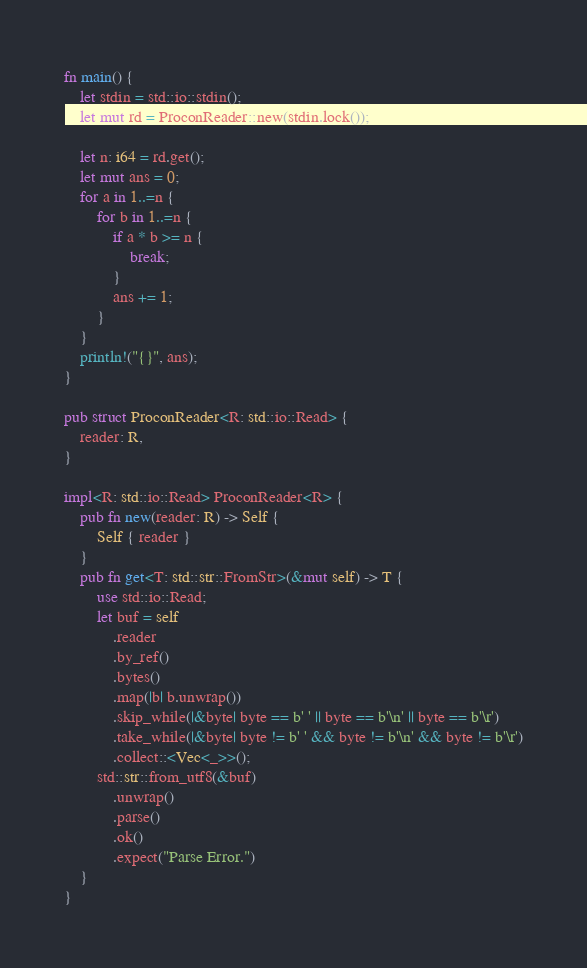Convert code to text. <code><loc_0><loc_0><loc_500><loc_500><_Rust_>fn main() {
    let stdin = std::io::stdin();
    let mut rd = ProconReader::new(stdin.lock());

    let n: i64 = rd.get();
    let mut ans = 0;
    for a in 1..=n {
        for b in 1..=n {
            if a * b >= n {
                break;
            }
            ans += 1;
        }
    }
    println!("{}", ans);
}

pub struct ProconReader<R: std::io::Read> {
    reader: R,
}

impl<R: std::io::Read> ProconReader<R> {
    pub fn new(reader: R) -> Self {
        Self { reader }
    }
    pub fn get<T: std::str::FromStr>(&mut self) -> T {
        use std::io::Read;
        let buf = self
            .reader
            .by_ref()
            .bytes()
            .map(|b| b.unwrap())
            .skip_while(|&byte| byte == b' ' || byte == b'\n' || byte == b'\r')
            .take_while(|&byte| byte != b' ' && byte != b'\n' && byte != b'\r')
            .collect::<Vec<_>>();
        std::str::from_utf8(&buf)
            .unwrap()
            .parse()
            .ok()
            .expect("Parse Error.")
    }
}</code> 